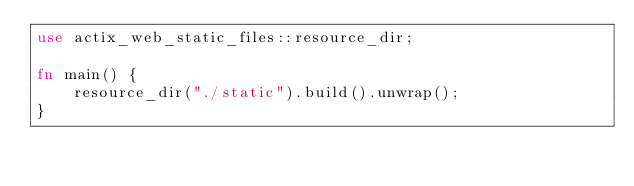Convert code to text. <code><loc_0><loc_0><loc_500><loc_500><_Rust_>use actix_web_static_files::resource_dir;

fn main() {
    resource_dir("./static").build().unwrap();
}

</code> 